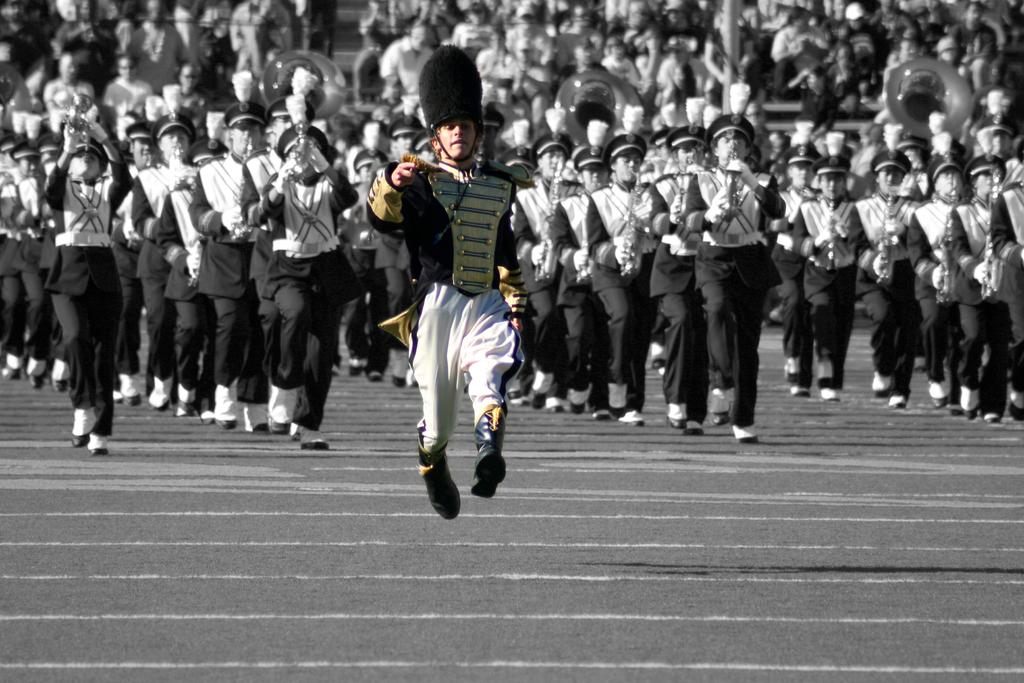Who or what can be seen in the image? There are people in the image. What are the people in the image doing? The people are marching on the ground. Can you describe the background of the image? There are people sitting on stairs in the background of the image. What type of haircut do the planes have in the image? There are no planes present in the image, so it is not possible to determine the type of haircut they might have. 